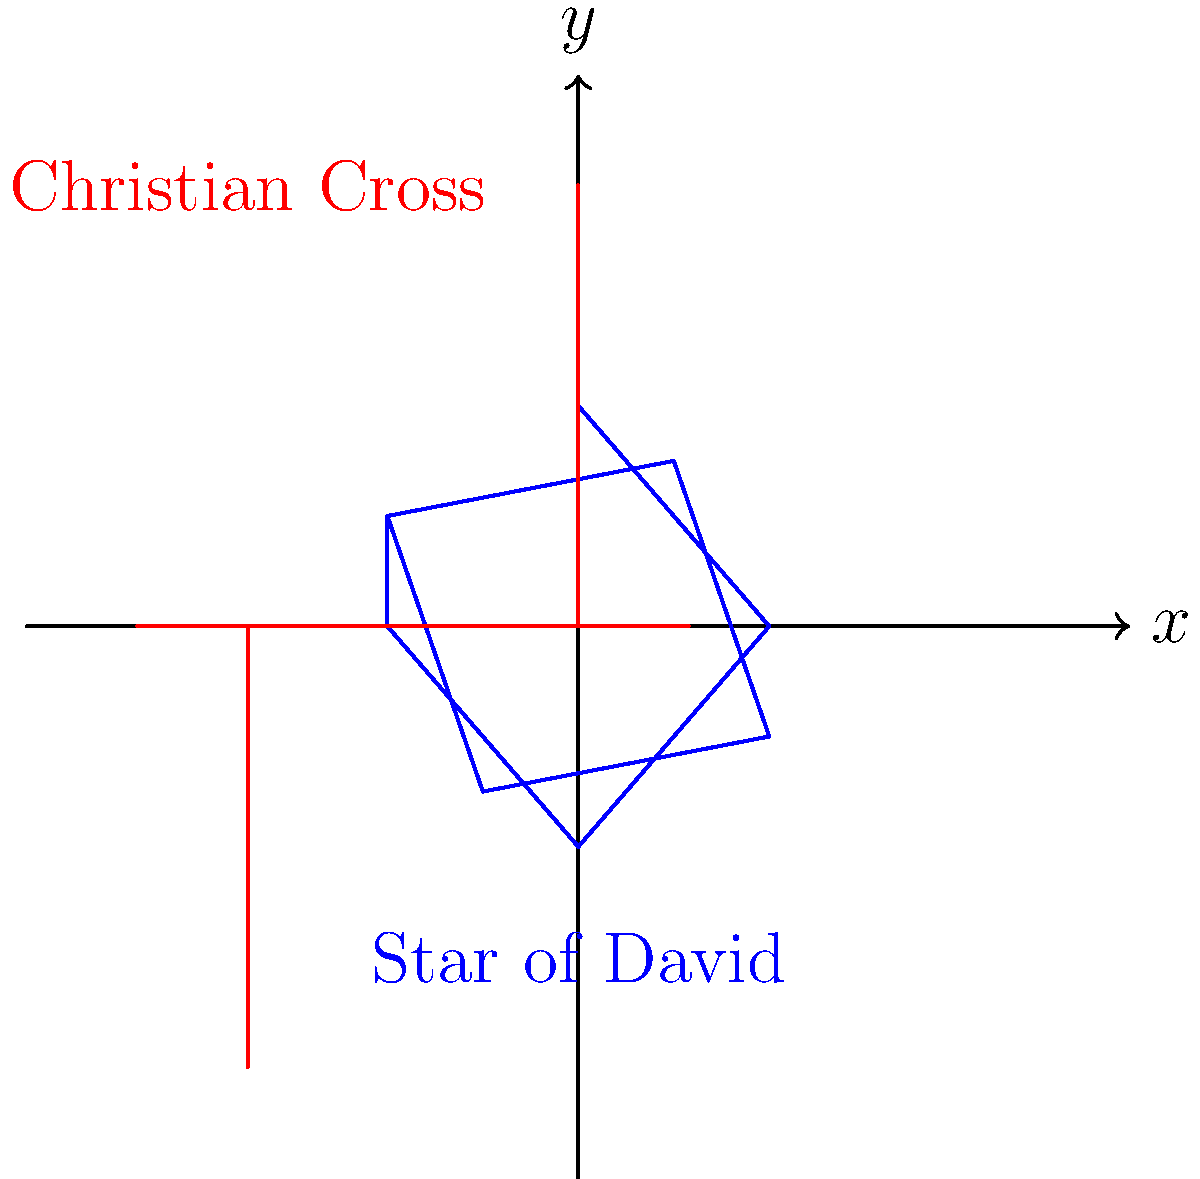In the coordinate plane above, two religious symbols are depicted: the Star of David and the Christian Cross. Given that the Star of David is centered at the origin and its topmost point is at $(0,2)$, determine the coordinates of the rightmost point of the Star of David. To find the coordinates of the rightmost point of the Star of David, we need to follow these steps:

1) The Star of David is composed of two equilateral triangles. Let's focus on the triangle that forms the right half of the star.

2) We know that the top point is at $(0,2)$ and the center is at $(0,0)$.

3) In an equilateral triangle, the distance from the center to any vertex is equal to the side length of the triangle.

4) The vertical distance from the center to the top point is 2 units.

5) In a 30-60-90 triangle (half of our equilateral triangle):
   - The shortest side (opposite to 30° angle) is $x$
   - The hypotenuse (opposite to 90° angle) is $2x$
   - The remaining side (opposite to 60° angle) is $x\sqrt{3}$

6) In our case, the hypotenuse is 2, so:
   $2x = 2$
   $x = 1$

7) The horizontal distance from the center to the rightmost point is therefore:
   $1\sqrt{3} \approx 1.732$

8) The y-coordinate of this point is 0, as it's on the x-axis.

Therefore, the coordinates of the rightmost point are $(1\sqrt{3}, 0)$ or approximately $(1.732, 0)$.
Answer: $(1\sqrt{3}, 0)$ or $(1.732, 0)$ 